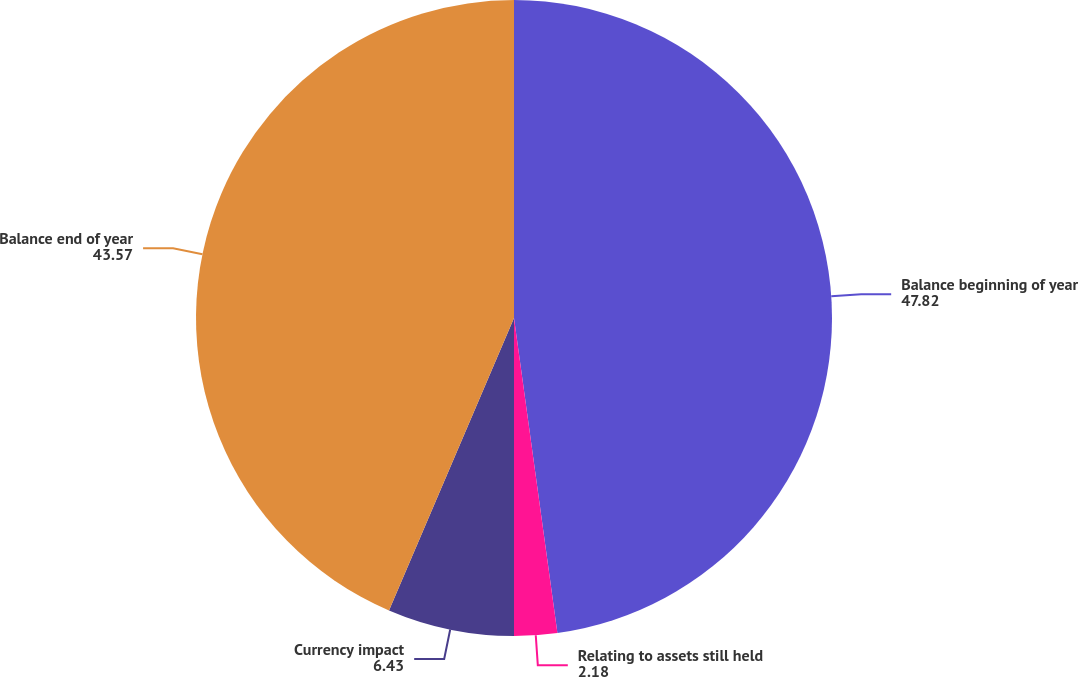Convert chart to OTSL. <chart><loc_0><loc_0><loc_500><loc_500><pie_chart><fcel>Balance beginning of year<fcel>Relating to assets still held<fcel>Currency impact<fcel>Balance end of year<nl><fcel>47.82%<fcel>2.18%<fcel>6.43%<fcel>43.57%<nl></chart> 